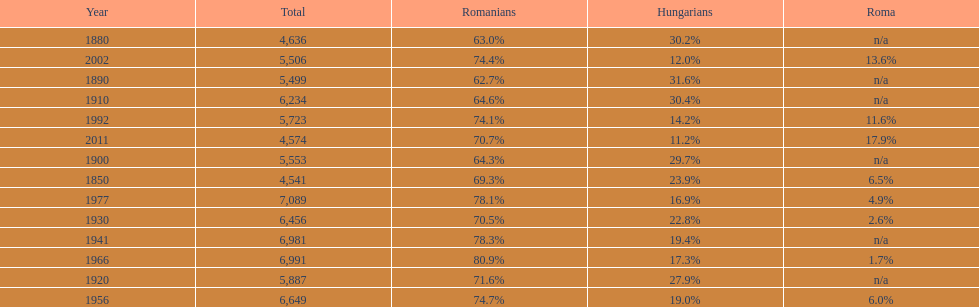Which year had a total of 6,981 and 19.4% hungarians? 1941. 